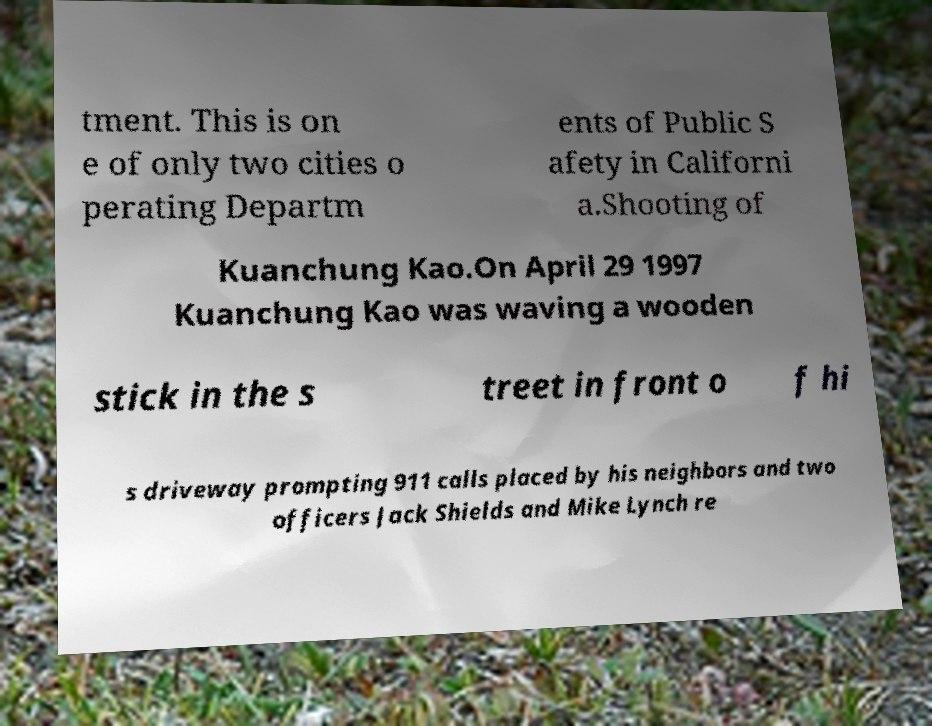For documentation purposes, I need the text within this image transcribed. Could you provide that? tment. This is on e of only two cities o perating Departm ents of Public S afety in Californi a.Shooting of Kuanchung Kao.On April 29 1997 Kuanchung Kao was waving a wooden stick in the s treet in front o f hi s driveway prompting 911 calls placed by his neighbors and two officers Jack Shields and Mike Lynch re 